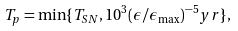Convert formula to latex. <formula><loc_0><loc_0><loc_500><loc_500>T _ { p } = \min \{ T _ { S N } , 1 0 ^ { 3 } ( \epsilon / \epsilon _ { \max } ) ^ { - 5 } y r \} ,</formula> 